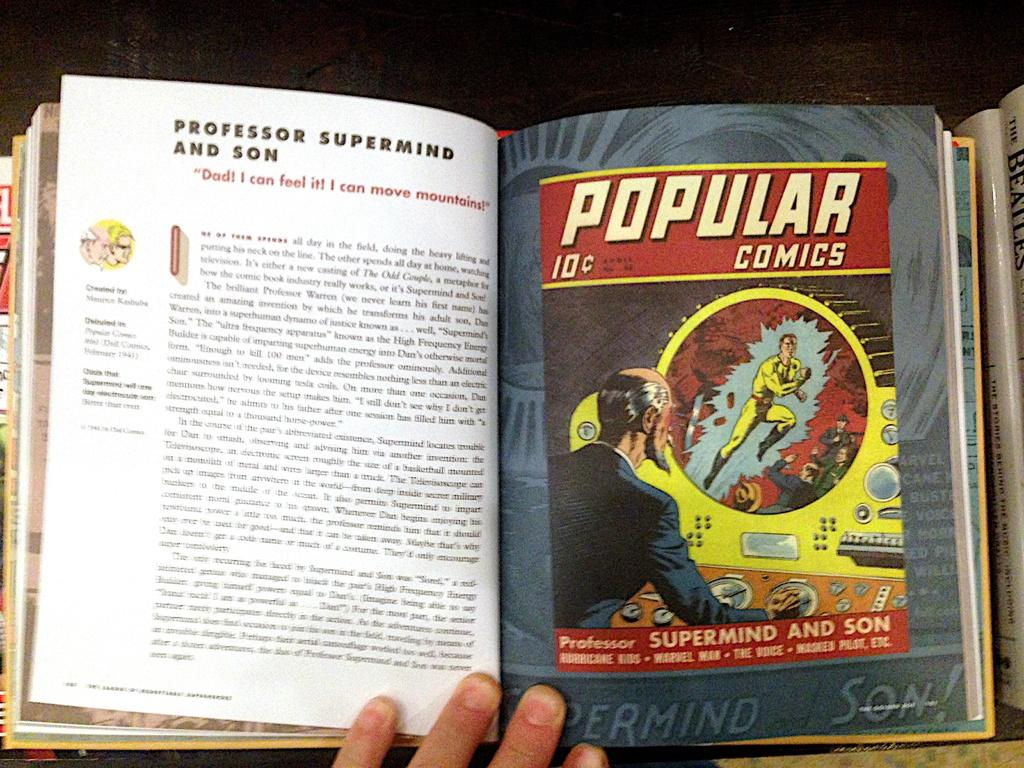<image>
Give a short and clear explanation of the subsequent image. A book includes a spread on Popular Comics and details the characters. 